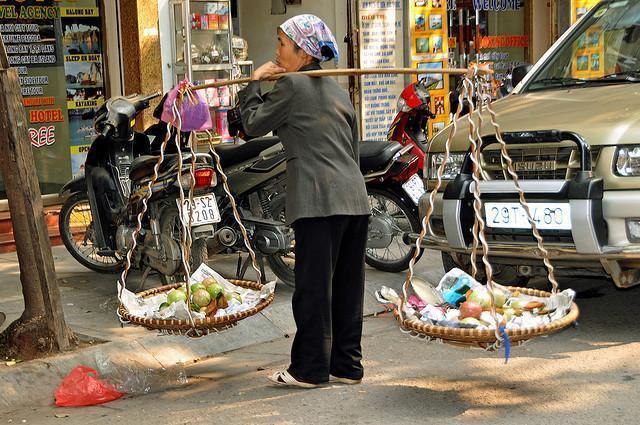How many motorcycles can be seen?
Give a very brief answer. 2. How many motorcycles are there?
Give a very brief answer. 3. How many blue umbrellas are in the image?
Give a very brief answer. 0. 